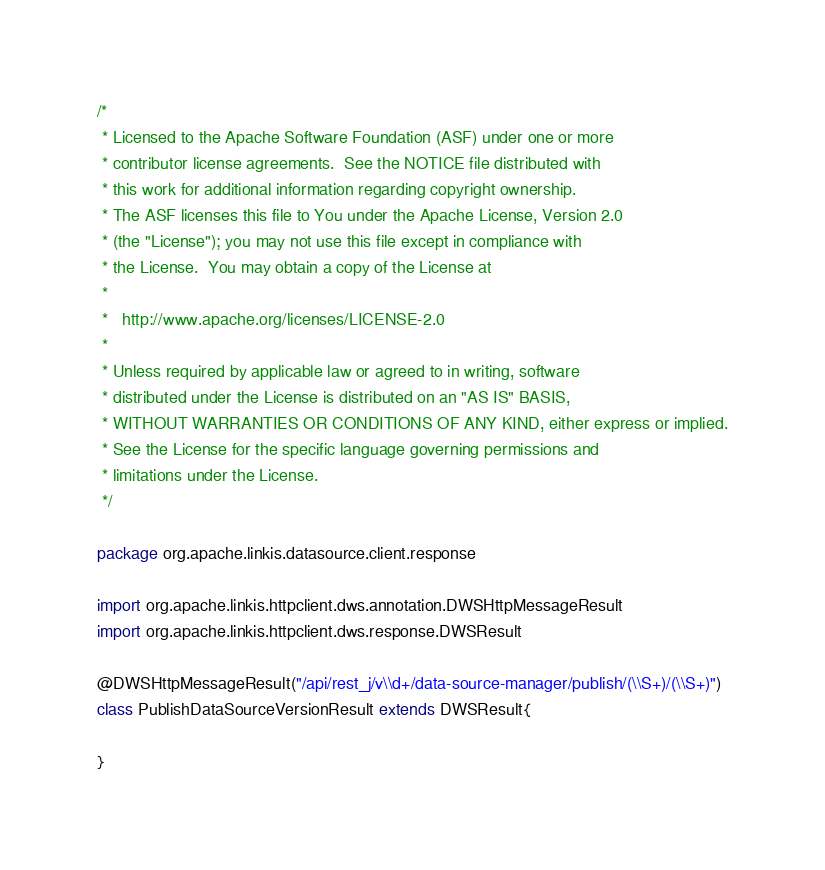Convert code to text. <code><loc_0><loc_0><loc_500><loc_500><_Scala_>/*
 * Licensed to the Apache Software Foundation (ASF) under one or more
 * contributor license agreements.  See the NOTICE file distributed with
 * this work for additional information regarding copyright ownership.
 * The ASF licenses this file to You under the Apache License, Version 2.0
 * (the "License"); you may not use this file except in compliance with
 * the License.  You may obtain a copy of the License at
 *
 *   http://www.apache.org/licenses/LICENSE-2.0
 *
 * Unless required by applicable law or agreed to in writing, software
 * distributed under the License is distributed on an "AS IS" BASIS,
 * WITHOUT WARRANTIES OR CONDITIONS OF ANY KIND, either express or implied.
 * See the License for the specific language governing permissions and
 * limitations under the License.
 */

package org.apache.linkis.datasource.client.response

import org.apache.linkis.httpclient.dws.annotation.DWSHttpMessageResult
import org.apache.linkis.httpclient.dws.response.DWSResult

@DWSHttpMessageResult("/api/rest_j/v\\d+/data-source-manager/publish/(\\S+)/(\\S+)")
class PublishDataSourceVersionResult extends DWSResult{

}
</code> 